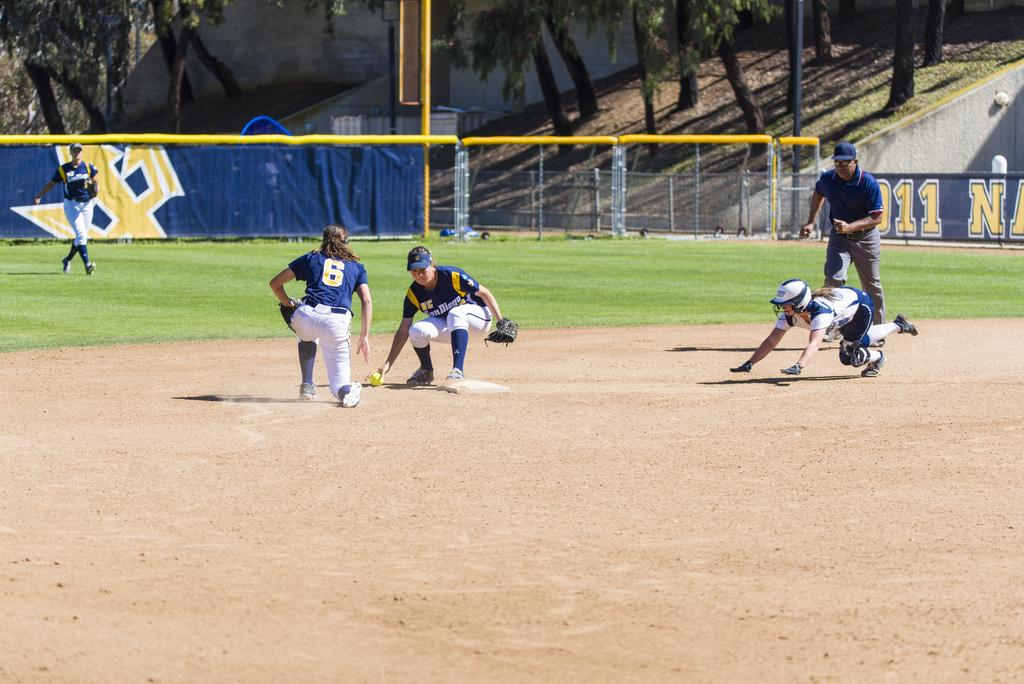<image>
Create a compact narrative representing the image presented. Baseball player wearing number 6 trying to touch the base. 